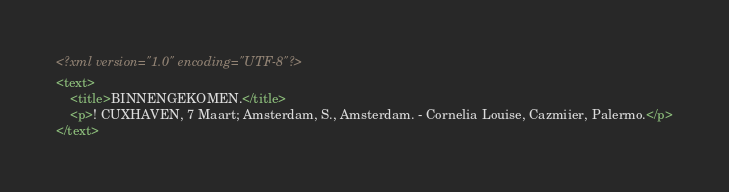Convert code to text. <code><loc_0><loc_0><loc_500><loc_500><_XML_><?xml version="1.0" encoding="UTF-8"?>
<text>
	<title>BINNENGEKOMEN.</title>
	<p>! CUXHAVEN, 7 Maart; Amsterdam, S., Amsterdam. - Cornelia Louise, Cazmiier, Palermo.</p>
</text>
</code> 